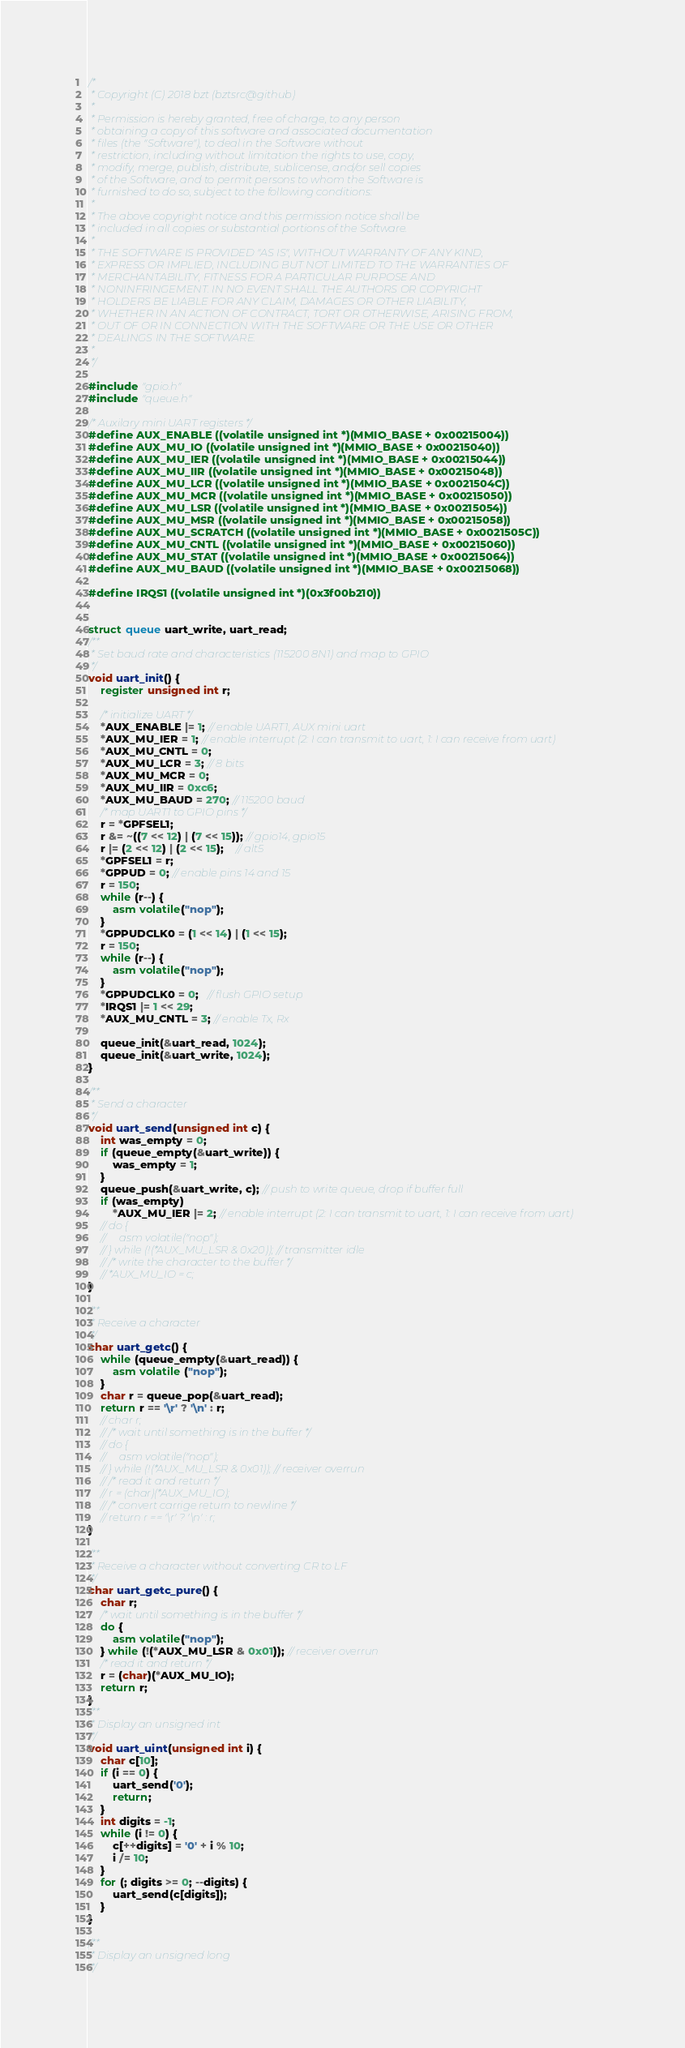Convert code to text. <code><loc_0><loc_0><loc_500><loc_500><_C_>/*
 * Copyright (C) 2018 bzt (bztsrc@github)
 *
 * Permission is hereby granted, free of charge, to any person
 * obtaining a copy of this software and associated documentation
 * files (the "Software"), to deal in the Software without
 * restriction, including without limitation the rights to use, copy,
 * modify, merge, publish, distribute, sublicense, and/or sell copies
 * of the Software, and to permit persons to whom the Software is
 * furnished to do so, subject to the following conditions:
 *
 * The above copyright notice and this permission notice shall be
 * included in all copies or substantial portions of the Software.
 *
 * THE SOFTWARE IS PROVIDED "AS IS", WITHOUT WARRANTY OF ANY KIND,
 * EXPRESS OR IMPLIED, INCLUDING BUT NOT LIMITED TO THE WARRANTIES OF
 * MERCHANTABILITY, FITNESS FOR A PARTICULAR PURPOSE AND
 * NONINFRINGEMENT. IN NO EVENT SHALL THE AUTHORS OR COPYRIGHT
 * HOLDERS BE LIABLE FOR ANY CLAIM, DAMAGES OR OTHER LIABILITY,
 * WHETHER IN AN ACTION OF CONTRACT, TORT OR OTHERWISE, ARISING FROM,
 * OUT OF OR IN CONNECTION WITH THE SOFTWARE OR THE USE OR OTHER
 * DEALINGS IN THE SOFTWARE.
 *
 */

#include "gpio.h"
#include "queue.h"

/* Auxilary mini UART registers */
#define AUX_ENABLE ((volatile unsigned int *)(MMIO_BASE + 0x00215004))
#define AUX_MU_IO ((volatile unsigned int *)(MMIO_BASE + 0x00215040))
#define AUX_MU_IER ((volatile unsigned int *)(MMIO_BASE + 0x00215044))
#define AUX_MU_IIR ((volatile unsigned int *)(MMIO_BASE + 0x00215048))
#define AUX_MU_LCR ((volatile unsigned int *)(MMIO_BASE + 0x0021504C))
#define AUX_MU_MCR ((volatile unsigned int *)(MMIO_BASE + 0x00215050))
#define AUX_MU_LSR ((volatile unsigned int *)(MMIO_BASE + 0x00215054))
#define AUX_MU_MSR ((volatile unsigned int *)(MMIO_BASE + 0x00215058))
#define AUX_MU_SCRATCH ((volatile unsigned int *)(MMIO_BASE + 0x0021505C))
#define AUX_MU_CNTL ((volatile unsigned int *)(MMIO_BASE + 0x00215060))
#define AUX_MU_STAT ((volatile unsigned int *)(MMIO_BASE + 0x00215064))
#define AUX_MU_BAUD ((volatile unsigned int *)(MMIO_BASE + 0x00215068))

#define IRQS1 ((volatile unsigned int *)(0x3f00b210))


struct queue uart_write, uart_read;
/**
 * Set baud rate and characteristics (115200 8N1) and map to GPIO
 */
void uart_init() {
    register unsigned int r;

    /* initialize UART */
    *AUX_ENABLE |= 1; // enable UART1, AUX mini uart
    *AUX_MU_IER = 1; // enable interrupt (2: I can transmit to uart, 1: I can receive from uart)
    *AUX_MU_CNTL = 0;
    *AUX_MU_LCR = 3; // 8 bits
    *AUX_MU_MCR = 0;
    *AUX_MU_IIR = 0xc6;
    *AUX_MU_BAUD = 270; // 115200 baud
    /* map UART1 to GPIO pins */
    r = *GPFSEL1;
    r &= ~((7 << 12) | (7 << 15)); // gpio14, gpio15
    r |= (2 << 12) | (2 << 15);    // alt5
    *GPFSEL1 = r;
    *GPPUD = 0; // enable pins 14 and 15
    r = 150;
    while (r--) {
        asm volatile("nop");
    }
    *GPPUDCLK0 = (1 << 14) | (1 << 15);
    r = 150;
    while (r--) {
        asm volatile("nop");
    }
    *GPPUDCLK0 = 0;   // flush GPIO setup
    *IRQS1 |= 1 << 29;
    *AUX_MU_CNTL = 3; // enable Tx, Rx

    queue_init(&uart_read, 1024);
    queue_init(&uart_write, 1024);
}

/**
 * Send a character
 */
void uart_send(unsigned int c) {
    int was_empty = 0;
    if (queue_empty(&uart_write)) {
        was_empty = 1;
    }
    queue_push(&uart_write, c); // push to write queue, drop if buffer full
    if (was_empty)
        *AUX_MU_IER |= 2; // enable interrupt (2: I can transmit to uart, 1: I can receive from uart)
    // do {
    //     asm volatile("nop");
    // } while (!(*AUX_MU_LSR & 0x20)); // transmitter idle
    // /* write the character to the buffer */
    // *AUX_MU_IO = c;
}

/**
 * Receive a character
 */
char uart_getc() {
    while (queue_empty(&uart_read)) {
        asm volatile ("nop");
    }
    char r = queue_pop(&uart_read);
    return r == '\r' ? '\n' : r;
    // char r;
    // /* wait until something is in the buffer */
    // do {
    //     asm volatile("nop");
    // } while (!(*AUX_MU_LSR & 0x01)); // receiver overrun
    // /* read it and return */
    // r = (char)(*AUX_MU_IO);
    // /* convert carrige return to newline */
    // return r == '\r' ? '\n' : r;
}

/**
 * Receive a character without converting CR to LF
 */
char uart_getc_pure() {
    char r;
    /* wait until something is in the buffer */
    do {
        asm volatile("nop");
    } while (!(*AUX_MU_LSR & 0x01)); // receiver overrun
    /* read it and return */
    r = (char)(*AUX_MU_IO);
    return r;
}
/**
 * Display an unsigned int
 */
void uart_uint(unsigned int i) {
    char c[10];
    if (i == 0) {
        uart_send('0');
        return;
    }
    int digits = -1;
    while (i != 0) {
        c[++digits] = '0' + i % 10;
        i /= 10;
    }
    for (; digits >= 0; --digits) {
        uart_send(c[digits]);
    }
}

/**
 * Display an unsigned long
 */</code> 